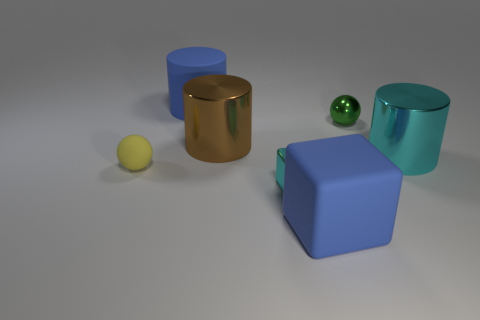Subtract all brown metallic cylinders. How many cylinders are left? 2 Add 1 small yellow rubber spheres. How many objects exist? 8 Subtract 3 cylinders. How many cylinders are left? 0 Subtract all blue cylinders. How many cylinders are left? 2 Subtract all cylinders. How many objects are left? 4 Subtract all yellow balls. Subtract all green blocks. How many balls are left? 1 Subtract all brown balls. How many cyan cubes are left? 1 Subtract all large blue matte blocks. Subtract all rubber cylinders. How many objects are left? 5 Add 1 large shiny things. How many large shiny things are left? 3 Add 5 small purple shiny cylinders. How many small purple shiny cylinders exist? 5 